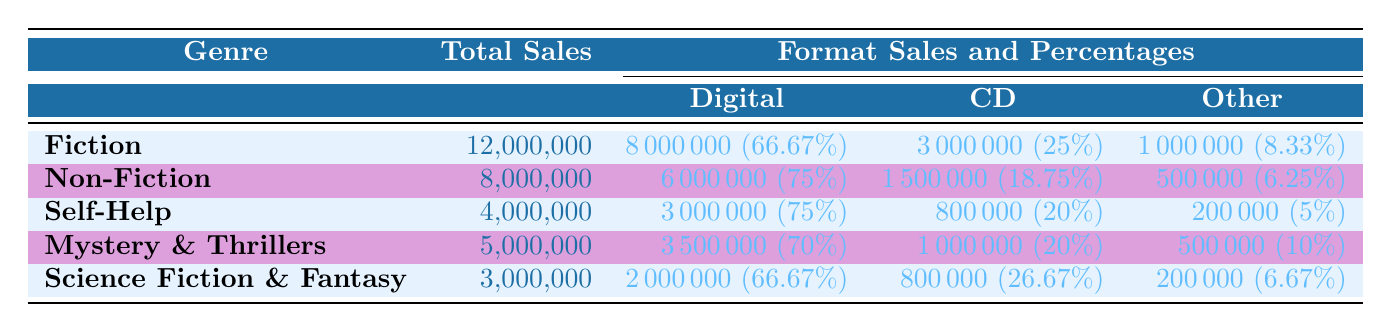What is the total sales for the Fiction genre? The total sales for the Fiction genre is listed directly in the table under the Total Sales column for Fiction, which shows 12,000,000.
Answer: 12,000,000 How much of the Non-Fiction sales were from Digital formats? For Non-Fiction, the Digital sales are 6,000,000, which is stated directly in the Formats section next to Non-Fiction.
Answer: 6,000,000 Is the percentage of Self-Help sales from Digital formats higher than that of Mystery & Thrillers? The percentage of Digital sales for Self-Help is 75%, while for Mystery & Thrillers it is 70%. Since 75% is greater than 70%, the statement is true.
Answer: Yes What is the combined total sales of CD formats for all genres? To find the combined total sales of CD formats, add the CD sales from each genre: 3,000,000 (Fiction) + 1,500,000 (Non-Fiction) + 800,000 (Self-Help) + 1,000,000 (Mystery & Thrillers) + 800,000 (Science Fiction & Fantasy), which equals 7,100,000.
Answer: 7,100,000 Which genre has the lowest total sales, and what is that amount? By comparing the Total Sales values listed for each genre, Science Fiction & Fantasy has the lowest at 3,000,000, making it the genre with the least total sales.
Answer: Science Fiction & Fantasy, 3,000,000 What percentage of total sales in the Fiction genre comes from the 'Other' category? The 'Other' category for Fiction has sales of 1,000,000. To find the percentage, divide the Other sales by the Total Sales for Fiction and multiply by 100: (1,000,000 / 12,000,000) * 100, which is 8.33%.
Answer: 8.33% Which format accounts for the highest percentage of total sales in Non-Fiction? In Non-Fiction, the format with the highest percentage of sales is Digital, which accounts for 75% of the total sales, as indicated in the Formats section next to Non-Fiction.
Answer: Digital format, 75% How do the total sales of Science Fiction & Fantasy compare to those of Self-Help? Science Fiction & Fantasy has total sales of 3,000,000 while Self-Help has 4,000,000. Since 4,000,000 is greater than 3,000,000, Self-Help has higher total sales than Science Fiction & Fantasy.
Answer: Self-Help has higher sales What is the total percentage of sales for the 'Other' category across all genres? The total percentage of sales for the 'Other' category must be calculated by adding the percentages given for each genre: 8.33% (Fiction) + 6.25% (Non-Fiction) + 5% (Self-Help) + 10% (Mystery & Thrillers) + 6.67% (Science Fiction & Fantasy), which equals 36.25%.
Answer: 36.25% 